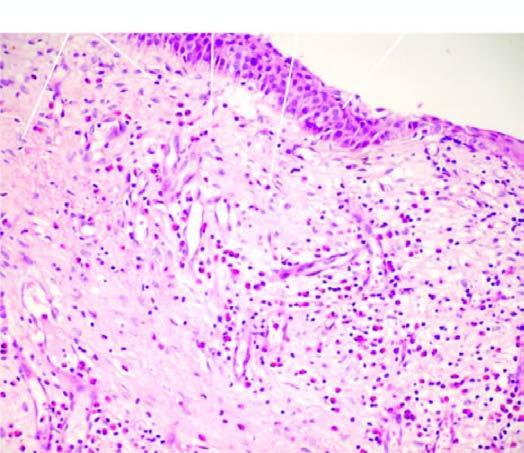what is the overlying mucosa covered partly by?
Answer the question using a single word or phrase. Respiratory and partly by squamous metaplastic epithelium 